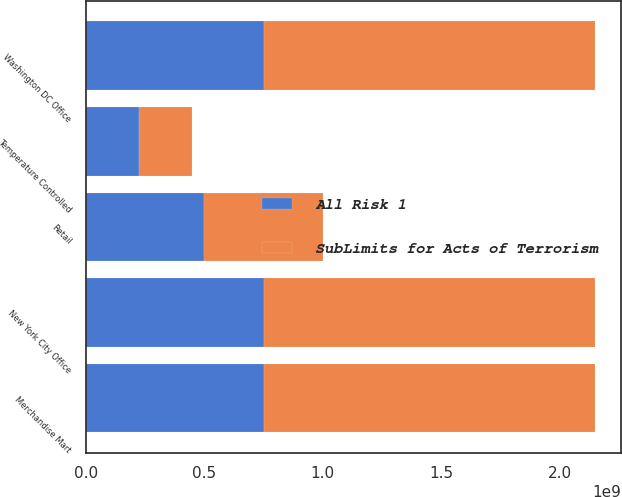Convert chart to OTSL. <chart><loc_0><loc_0><loc_500><loc_500><stacked_bar_chart><ecel><fcel>New York City Office<fcel>Washington DC Office<fcel>Retail<fcel>Merchandise Mart<fcel>Temperature Controlled<nl><fcel>SubLimits for Acts of Terrorism<fcel>1.4e+09<fcel>1.4e+09<fcel>5e+08<fcel>1.4e+09<fcel>2.25e+08<nl><fcel>All Risk 1<fcel>7.5e+08<fcel>7.5e+08<fcel>5e+08<fcel>7.5e+08<fcel>2.25e+08<nl></chart> 